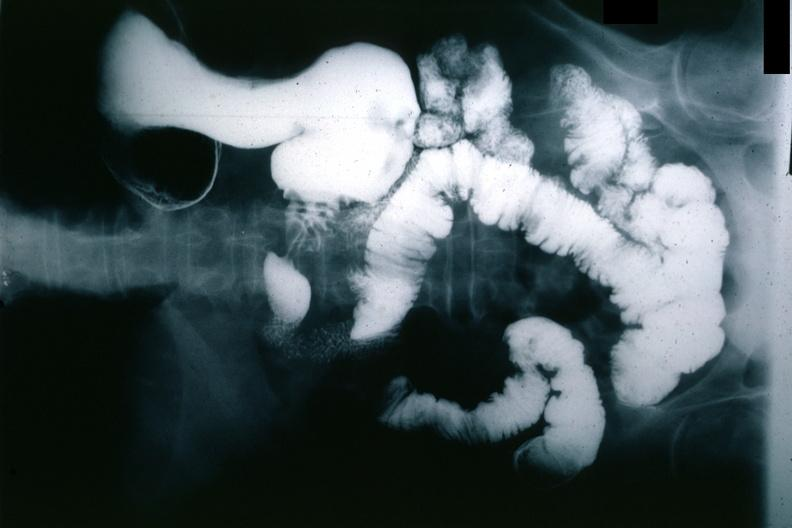s stomach present?
Answer the question using a single word or phrase. Yes 